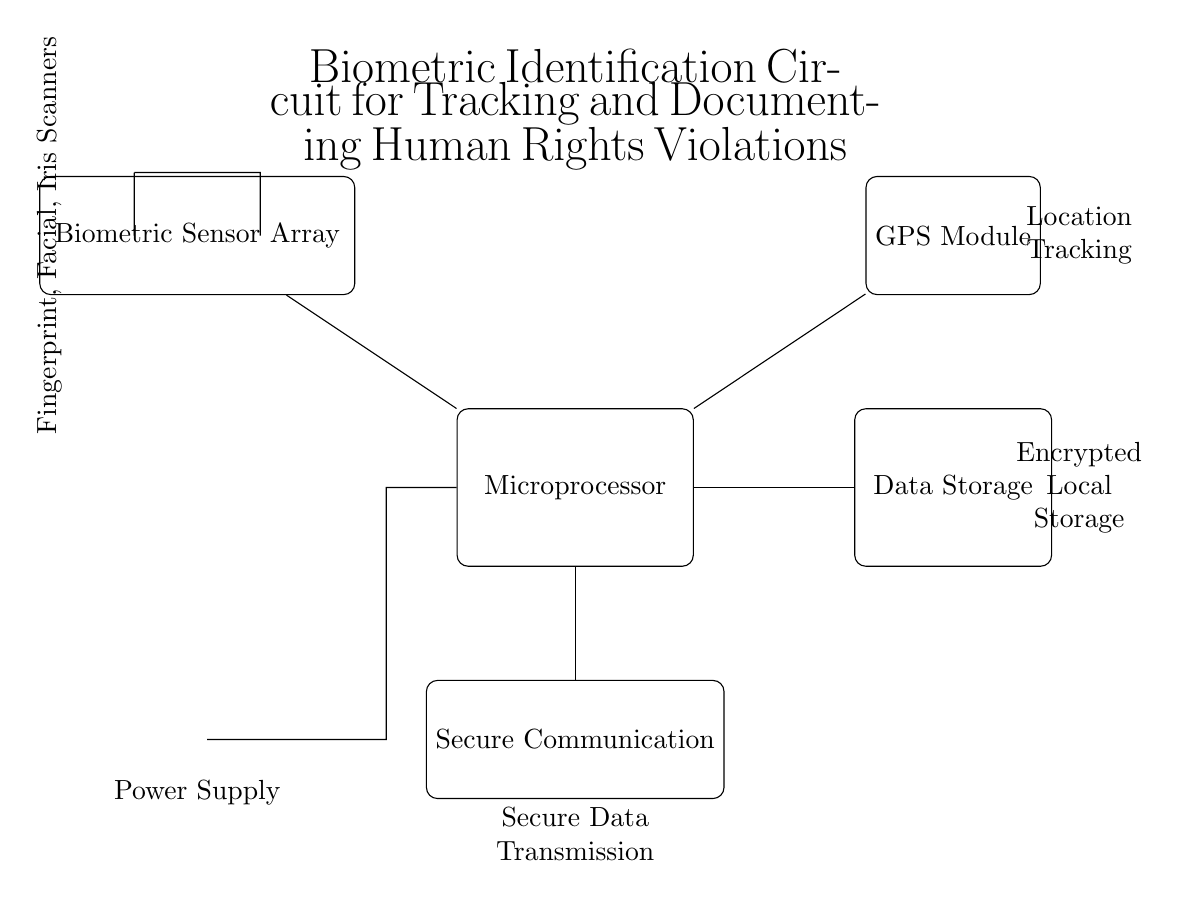What is the main processing unit in this circuit? The main processing unit is labeled as "Microprocessor" in the circuit diagram.
Answer: Microprocessor What types of biometric sensors are included? The circuit diagram lists the biometric sensors as "Fingerprint, Facial, Iris Scanners" next to the sensor array component.
Answer: Fingerprint, Facial, Iris Scanners What does the data storage component provide? The data storage component is labeled as "Encrypted Local Storage," indicating that it will securely hold the data collected by the biometric sensors.
Answer: Encrypted Local Storage What is the purpose of the GPS module in this circuit? The GPS module is labeled as providing "Location Tracking," which means it functions to determine the geographic location of the device in use.
Answer: Location Tracking How does the power supply connect to the microprocessor? The power supply, represented by a battery symbol, is connected to the microprocessor through short connections that lead from the battery to the microprocessor.
Answer: Short connections What is indicated by the secure communication module? The secure communication module is labeled "Secure Data Transmission," suggesting its role in transmitting data securely from the device to other systems.
Answer: Secure Data Transmission Why is the microprocessor central to this circuit? The microprocessor is central because it processes inputs from the biometric sensor array, manages data storage, and oversees communication with the GPS module and secure communication.
Answer: Central processing 